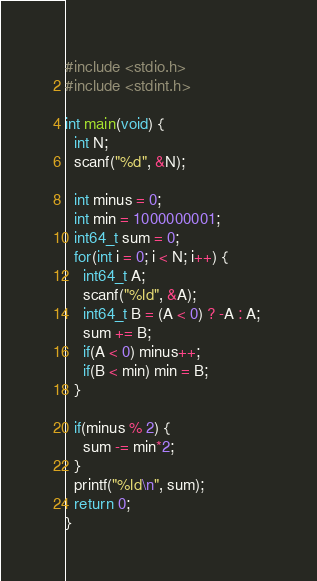Convert code to text. <code><loc_0><loc_0><loc_500><loc_500><_C_>#include <stdio.h>
#include <stdint.h>

int main(void) {
  int N;
  scanf("%d", &N);

  int minus = 0;
  int min = 1000000001;
  int64_t sum = 0;
  for(int i = 0; i < N; i++) {
    int64_t A;
    scanf("%ld", &A);
    int64_t B = (A < 0) ? -A : A; 
    sum += B;
    if(A < 0) minus++;
    if(B < min) min = B;
  }

  if(minus % 2) {
    sum -= min*2;
  }
  printf("%ld\n", sum);
  return 0;
}
</code> 